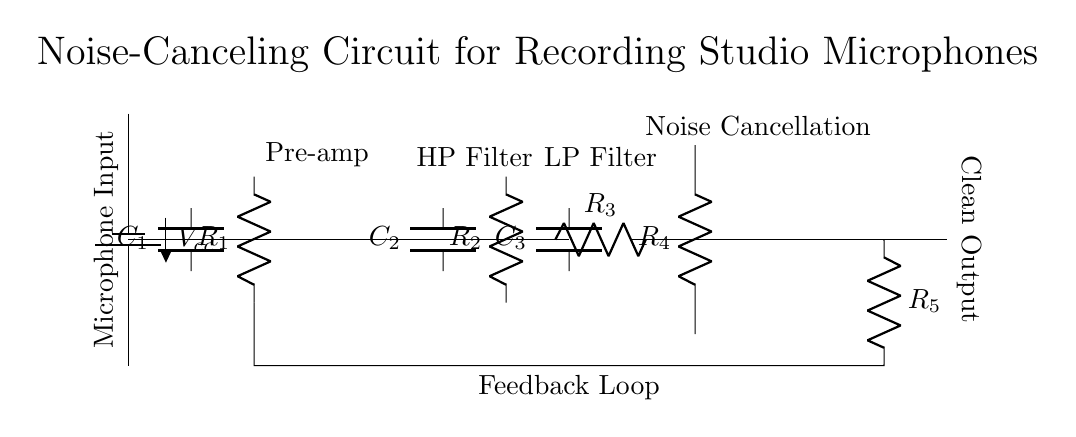What is the main purpose of this circuit? The main purpose of this circuit is to cancel noise in a recording studio microphone setup, providing a clean audio output.
Answer: Noise cancellation What are the components used in the noise-canceling section? The noise-canceling section includes a resistor labeled R4 and an operational amplifier. These components work together to enhance the audio quality by reducing unwanted noise.
Answer: R4 and op amp What type of filter is implemented after the pre-amplifier? A high-pass filter is implemented after the pre-amplifier, which allows high-frequency signals to pass while attenuating lower frequencies, helping to eliminate low-frequency noise.
Answer: High-pass filter What is the configuration of the feedback loop? The feedback loop consists of a resistor labeled R5 that connects the output of the noise-canceling section back to the input of the pre-amplifier, helping to stabilize the circuit.
Answer: Resistor R5 How many capacitors are present in this circuit? There are three capacitors (C1, C2, and C3) in the circuit used for filtering signals at different frequencies, contributing to the overall noise reduction functionality.
Answer: Three What role does the power supply play in this circuit? The power supply provides the necessary voltage for the operational amplifier and other components, ensuring they operate effectively to perform the noise cancellation process.
Answer: Voltage supply 